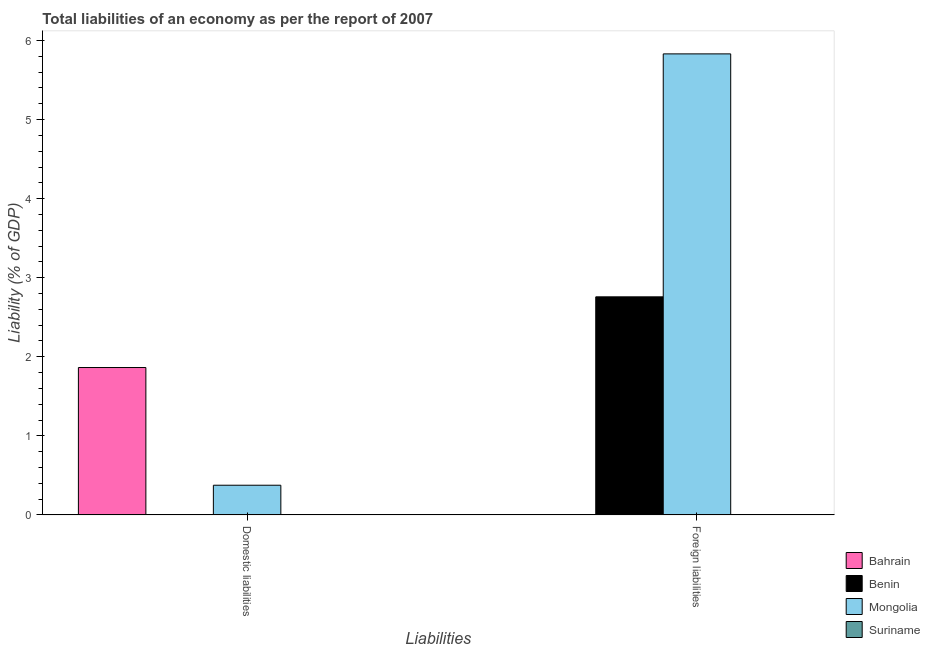How many different coloured bars are there?
Provide a succinct answer. 3. What is the label of the 1st group of bars from the left?
Provide a succinct answer. Domestic liabilities. What is the incurrence of domestic liabilities in Bahrain?
Your response must be concise. 1.86. Across all countries, what is the maximum incurrence of foreign liabilities?
Keep it short and to the point. 5.83. Across all countries, what is the minimum incurrence of foreign liabilities?
Keep it short and to the point. 0. In which country was the incurrence of foreign liabilities maximum?
Your answer should be compact. Mongolia. What is the total incurrence of foreign liabilities in the graph?
Make the answer very short. 8.59. What is the difference between the incurrence of foreign liabilities in Mongolia and that in Benin?
Give a very brief answer. 3.07. What is the difference between the incurrence of foreign liabilities in Benin and the incurrence of domestic liabilities in Bahrain?
Your response must be concise. 0.89. What is the average incurrence of domestic liabilities per country?
Your response must be concise. 0.56. What is the difference between the incurrence of foreign liabilities and incurrence of domestic liabilities in Mongolia?
Provide a short and direct response. 5.46. In how many countries, is the incurrence of domestic liabilities greater than 2.4 %?
Keep it short and to the point. 0. What is the ratio of the incurrence of foreign liabilities in Mongolia to that in Benin?
Offer a terse response. 2.11. How many bars are there?
Your response must be concise. 4. Are all the bars in the graph horizontal?
Your response must be concise. No. How many countries are there in the graph?
Your answer should be compact. 4. Are the values on the major ticks of Y-axis written in scientific E-notation?
Ensure brevity in your answer.  No. Does the graph contain grids?
Your answer should be compact. No. How many legend labels are there?
Keep it short and to the point. 4. What is the title of the graph?
Give a very brief answer. Total liabilities of an economy as per the report of 2007. Does "Moldova" appear as one of the legend labels in the graph?
Offer a terse response. No. What is the label or title of the X-axis?
Your answer should be compact. Liabilities. What is the label or title of the Y-axis?
Keep it short and to the point. Liability (% of GDP). What is the Liability (% of GDP) of Bahrain in Domestic liabilities?
Your response must be concise. 1.86. What is the Liability (% of GDP) of Benin in Domestic liabilities?
Offer a terse response. 0. What is the Liability (% of GDP) of Mongolia in Domestic liabilities?
Make the answer very short. 0.38. What is the Liability (% of GDP) of Benin in Foreign liabilities?
Provide a short and direct response. 2.76. What is the Liability (% of GDP) of Mongolia in Foreign liabilities?
Give a very brief answer. 5.83. What is the Liability (% of GDP) of Suriname in Foreign liabilities?
Your answer should be very brief. 0. Across all Liabilities, what is the maximum Liability (% of GDP) in Bahrain?
Provide a succinct answer. 1.86. Across all Liabilities, what is the maximum Liability (% of GDP) in Benin?
Your answer should be compact. 2.76. Across all Liabilities, what is the maximum Liability (% of GDP) of Mongolia?
Provide a succinct answer. 5.83. Across all Liabilities, what is the minimum Liability (% of GDP) of Mongolia?
Offer a terse response. 0.38. What is the total Liability (% of GDP) of Bahrain in the graph?
Provide a succinct answer. 1.86. What is the total Liability (% of GDP) in Benin in the graph?
Keep it short and to the point. 2.76. What is the total Liability (% of GDP) in Mongolia in the graph?
Provide a succinct answer. 6.21. What is the total Liability (% of GDP) in Suriname in the graph?
Give a very brief answer. 0. What is the difference between the Liability (% of GDP) in Mongolia in Domestic liabilities and that in Foreign liabilities?
Ensure brevity in your answer.  -5.46. What is the difference between the Liability (% of GDP) of Bahrain in Domestic liabilities and the Liability (% of GDP) of Benin in Foreign liabilities?
Your answer should be compact. -0.89. What is the difference between the Liability (% of GDP) of Bahrain in Domestic liabilities and the Liability (% of GDP) of Mongolia in Foreign liabilities?
Offer a terse response. -3.97. What is the average Liability (% of GDP) in Bahrain per Liabilities?
Offer a terse response. 0.93. What is the average Liability (% of GDP) of Benin per Liabilities?
Provide a succinct answer. 1.38. What is the average Liability (% of GDP) in Mongolia per Liabilities?
Ensure brevity in your answer.  3.1. What is the average Liability (% of GDP) of Suriname per Liabilities?
Give a very brief answer. 0. What is the difference between the Liability (% of GDP) of Bahrain and Liability (% of GDP) of Mongolia in Domestic liabilities?
Your response must be concise. 1.49. What is the difference between the Liability (% of GDP) of Benin and Liability (% of GDP) of Mongolia in Foreign liabilities?
Provide a short and direct response. -3.07. What is the ratio of the Liability (% of GDP) of Mongolia in Domestic liabilities to that in Foreign liabilities?
Give a very brief answer. 0.06. What is the difference between the highest and the second highest Liability (% of GDP) of Mongolia?
Your answer should be compact. 5.46. What is the difference between the highest and the lowest Liability (% of GDP) of Bahrain?
Keep it short and to the point. 1.86. What is the difference between the highest and the lowest Liability (% of GDP) in Benin?
Give a very brief answer. 2.76. What is the difference between the highest and the lowest Liability (% of GDP) in Mongolia?
Your response must be concise. 5.46. 